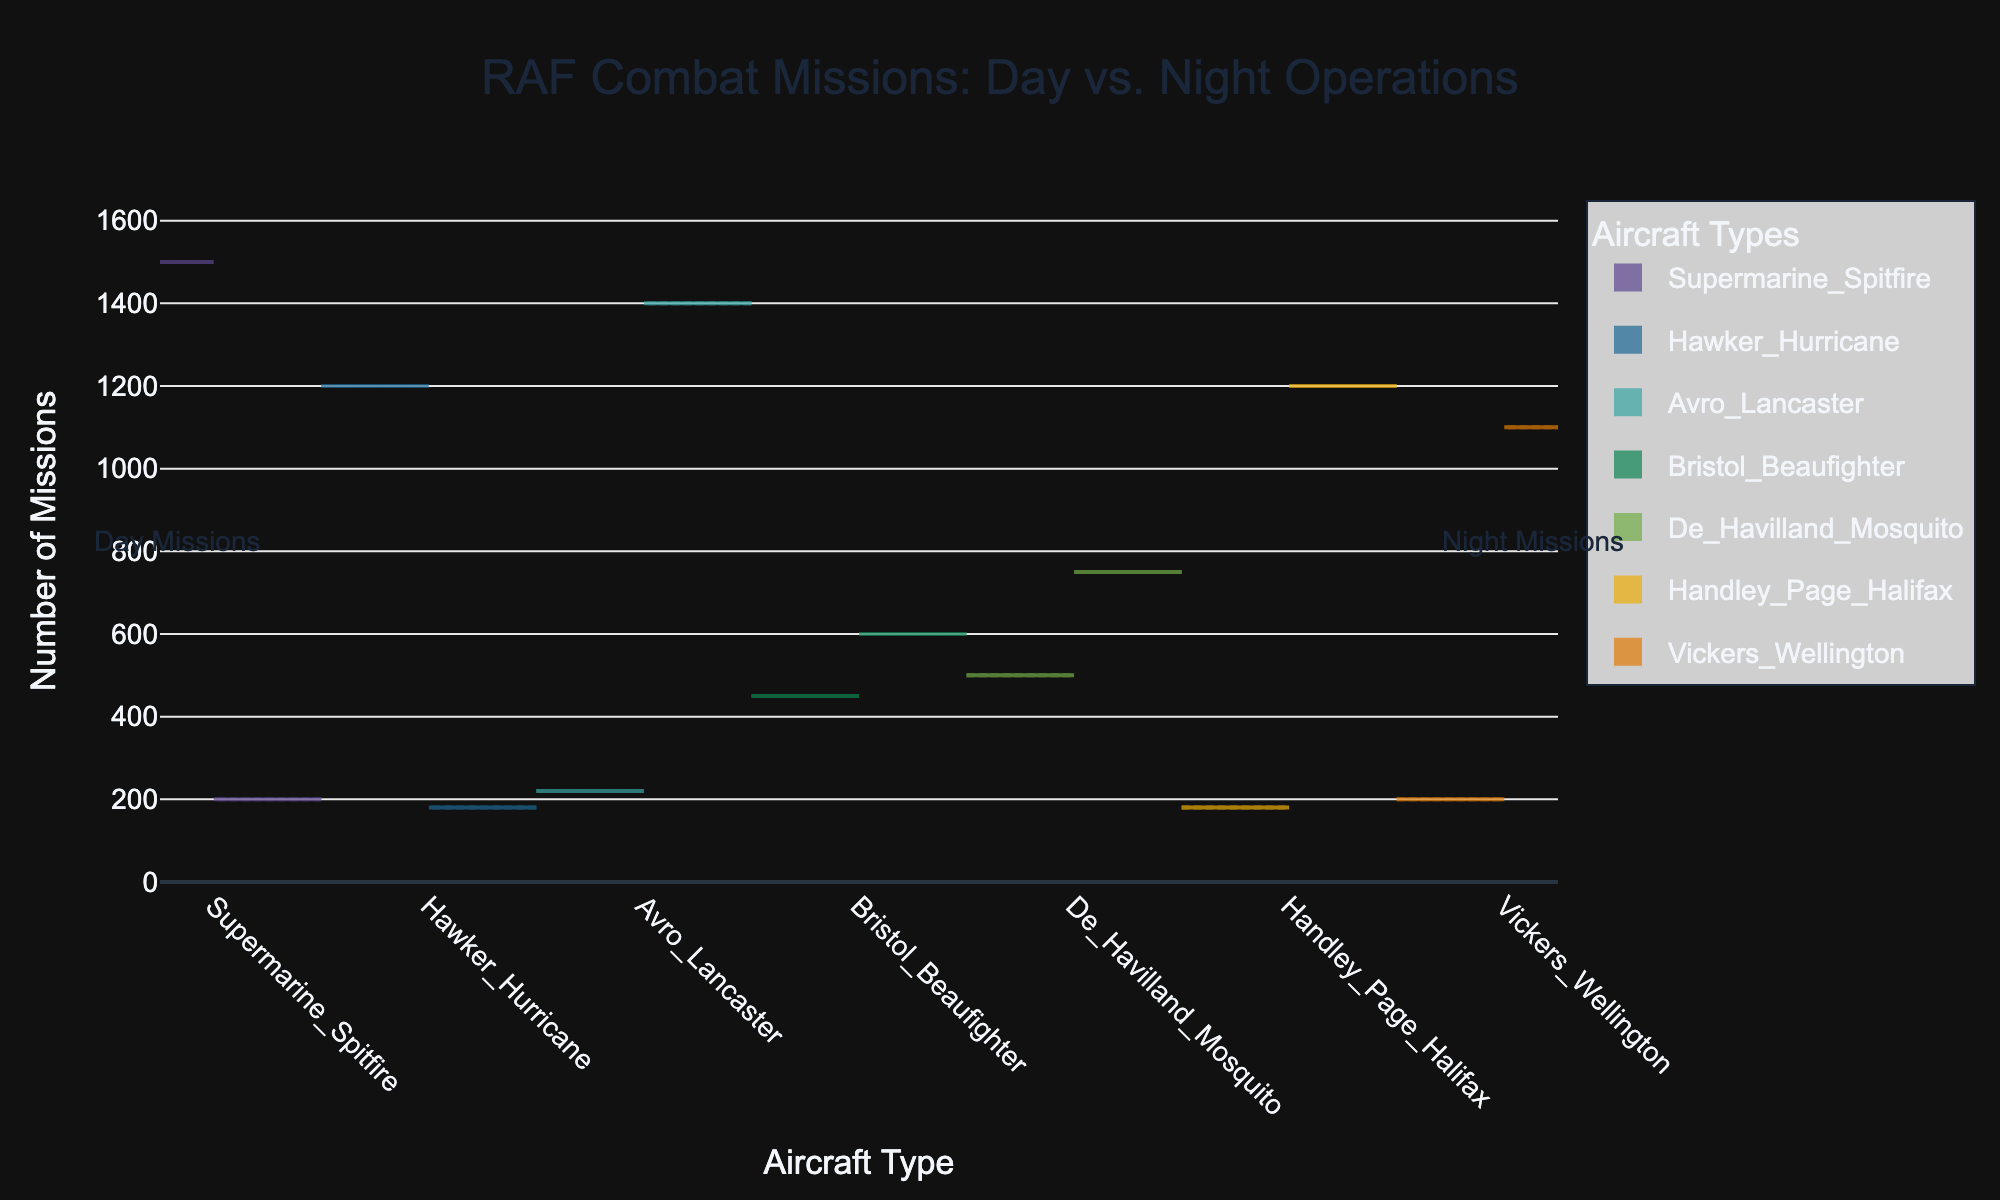What's the title of the figure? The title is usually located at the top of the figure. For this chart, the title as described in the code is "RAF Combat Missions: Day vs. Night Operations".
Answer: RAF Combat Missions: Day vs. Night Operations What are the axis titles? The x-axis title and y-axis title can be found directly below and to the left of the plot, respectively. According to the code, the x-axis title is "Aircraft Type" and the y-axis title is "Number of Missions".
Answer: Aircraft Type, Number of Missions Which aircraft type has the highest number of day missions? By looking at the left side of the split violin plot for each aircraft type, we can see that the Supermarine Spitfire has the highest peak, which corresponds to 1500 day missions.
Answer: Supermarine Spitfire Which aircraft type performs the most night missions? By observing the right side of the split violin plot for each aircraft type, Avro Lancaster shows the tallest peak on the right which indicates the highest number of night missions, standing at 1400 missions.
Answer: Avro Lancaster What is the combined number of day missions for the Bristol Beaufighter and De Havilland Mosquito? First, note the day missions for each: Bristol Beaufighter (450), De Havilland Mosquito (500). Adding them together (450 + 500) gives the combined total.
Answer: 950 How do the night missions of the Handley Page Halifax compare to the night missions of the Vickers Wellington? Look at the right side of the split violin plot for these aircraft: Handley Page Halifax has 1200 night missions, while Vickers Wellington has 1100 night missions. Comparing these numbers, Handley Page Halifax has more night missions.
Answer: Handley Page Halifax has more night missions Are there any aircraft types that have more night missions than day missions? To answer this, compare the left and right sides of the split violin for each aircraft type. Aircraft types with more night missions than day include Avro Lancaster, Bristol Beaufighter, De Havilland Mosquito, Handley Page Halifax, and Vickers Wellington.
Answer: Yes Which aircraft type has the smallest difference between day and night missions? By checking the absolute difference between day and night missions for each aircraft type, Bristol Beaufighter has missions (450 day, 600 night) which gives an absolute difference of 150. This is the smallest difference compared to others.
Answer: Bristol Beaufighter What does the width of the violin plot indicate? The width at each y-value (number of missions) indicates the density of missions at that value. Wider sections represent more frequent mission counts at that number.
Answer: Density of missions 